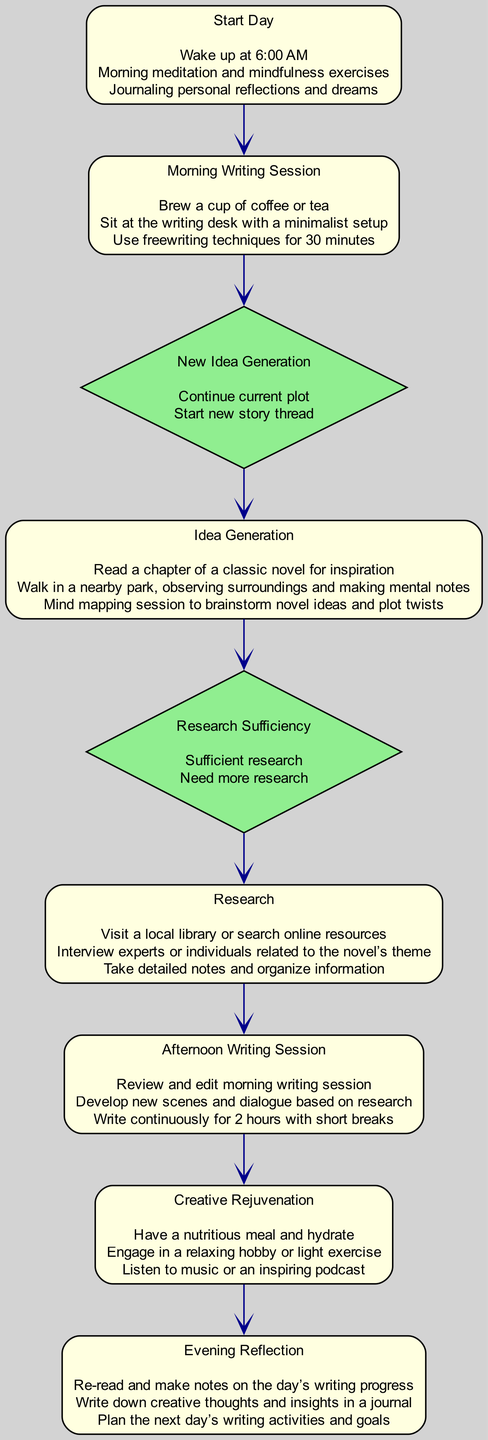What's the first activity of the day? The diagram indicates "Start Day" as the first activity, which begins the author's daily routine.
Answer: Start Day How many activities are there in total? Counting the nodes labeled as activities, there are seven distinct activities present in the diagram.
Answer: Seven What follows the "Morning Writing Session"? After the "Morning Writing Session," the flow leads to the decision point "New Idea Generation," where the author must make a decision on the next steps.
Answer: New Idea Generation What is the last activity before reaching the "Evening Reflection"? The last activity leading up to "Evening Reflection" is "Creative Rejuvenation," indicating that rejuvenation comes before reflecting on the day's work.
Answer: Creative Rejuvenation What are the two options in the "New Idea Generation" decision point? The options presented at the "New Idea Generation" decision point are "Continue current plot" and "Start new story thread," indicating the author's choices for further narrative development.
Answer: Continue current plot, Start new story thread How many decision points are featured in the diagram? There are two decision points illustrated in the diagram, including "New Idea Generation" and "Research Sufficiency."
Answer: Two If the author decides to continue developing the current plot, what is the next step? If the author chooses to continue with the current plot, they will proceed directly to the "Afternoon Writing Session" after the decision point labeled "New Idea Generation."
Answer: Afternoon Writing Session In which activity does the author conduct research? The activity where research is conducted is simply titled "Research," as it involves gathering information and ensuring authenticity in the novel's elements.
Answer: Research What is the purpose of the "Creative Rejuvenation" activity? The purpose of "Creative Rejuvenation" is to take breaks for relaxation and to avoid burnout, thereby maintaining creativity and productivity throughout the writing day.
Answer: Avoid burnout 